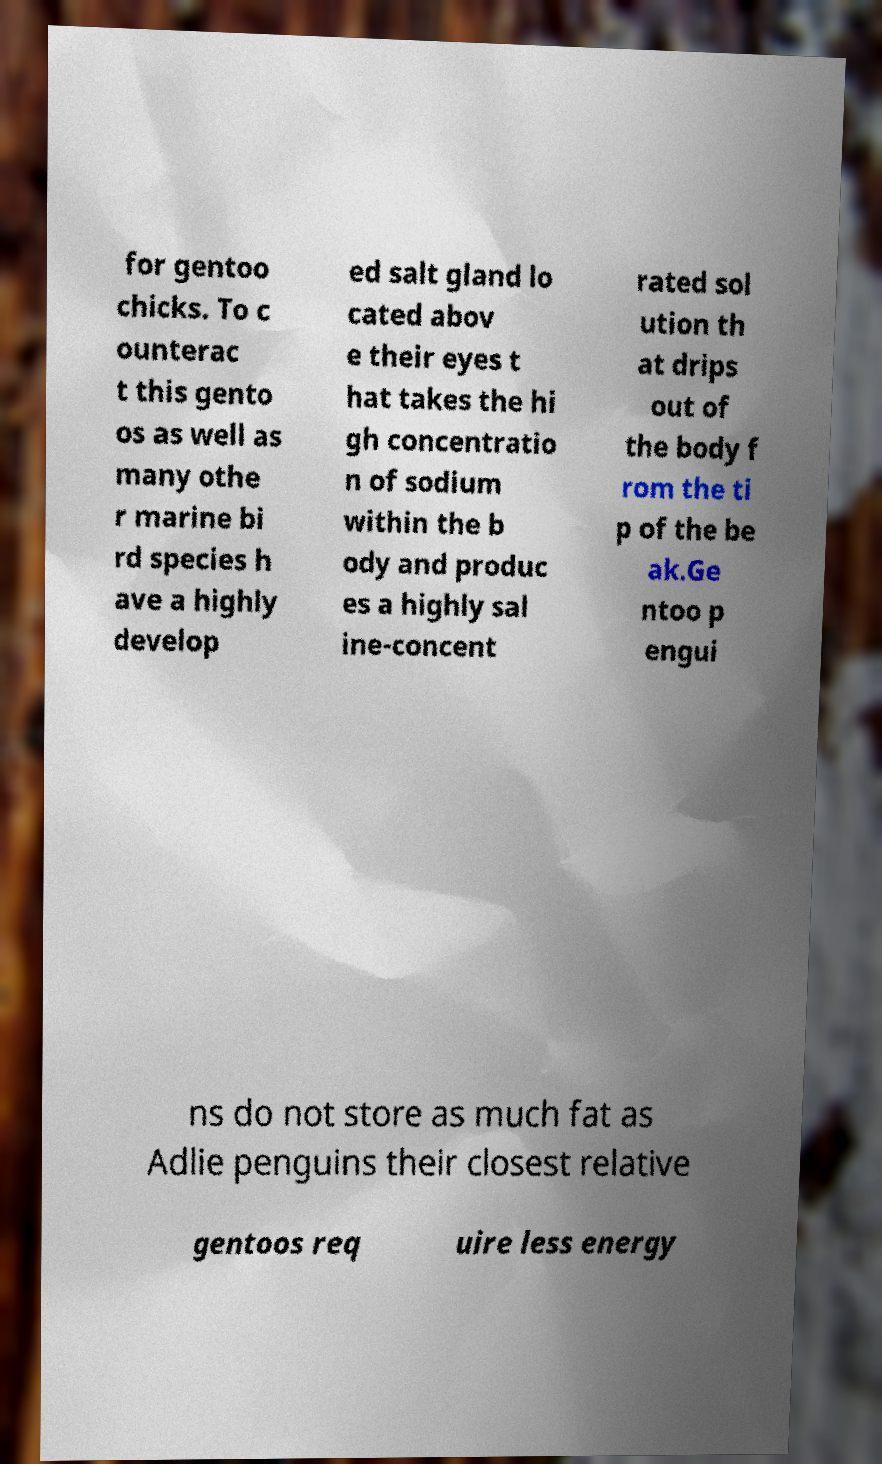Please identify and transcribe the text found in this image. for gentoo chicks. To c ounterac t this gento os as well as many othe r marine bi rd species h ave a highly develop ed salt gland lo cated abov e their eyes t hat takes the hi gh concentratio n of sodium within the b ody and produc es a highly sal ine-concent rated sol ution th at drips out of the body f rom the ti p of the be ak.Ge ntoo p engui ns do not store as much fat as Adlie penguins their closest relative gentoos req uire less energy 